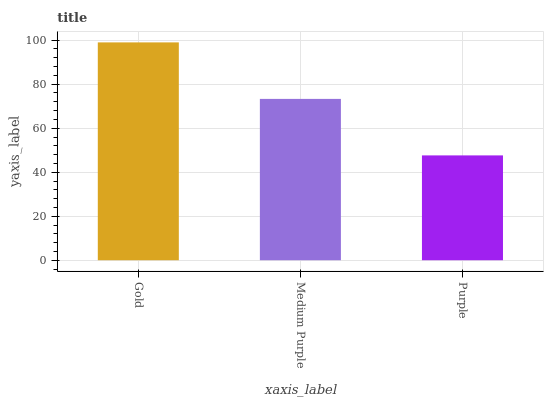Is Purple the minimum?
Answer yes or no. Yes. Is Gold the maximum?
Answer yes or no. Yes. Is Medium Purple the minimum?
Answer yes or no. No. Is Medium Purple the maximum?
Answer yes or no. No. Is Gold greater than Medium Purple?
Answer yes or no. Yes. Is Medium Purple less than Gold?
Answer yes or no. Yes. Is Medium Purple greater than Gold?
Answer yes or no. No. Is Gold less than Medium Purple?
Answer yes or no. No. Is Medium Purple the high median?
Answer yes or no. Yes. Is Medium Purple the low median?
Answer yes or no. Yes. Is Purple the high median?
Answer yes or no. No. Is Purple the low median?
Answer yes or no. No. 